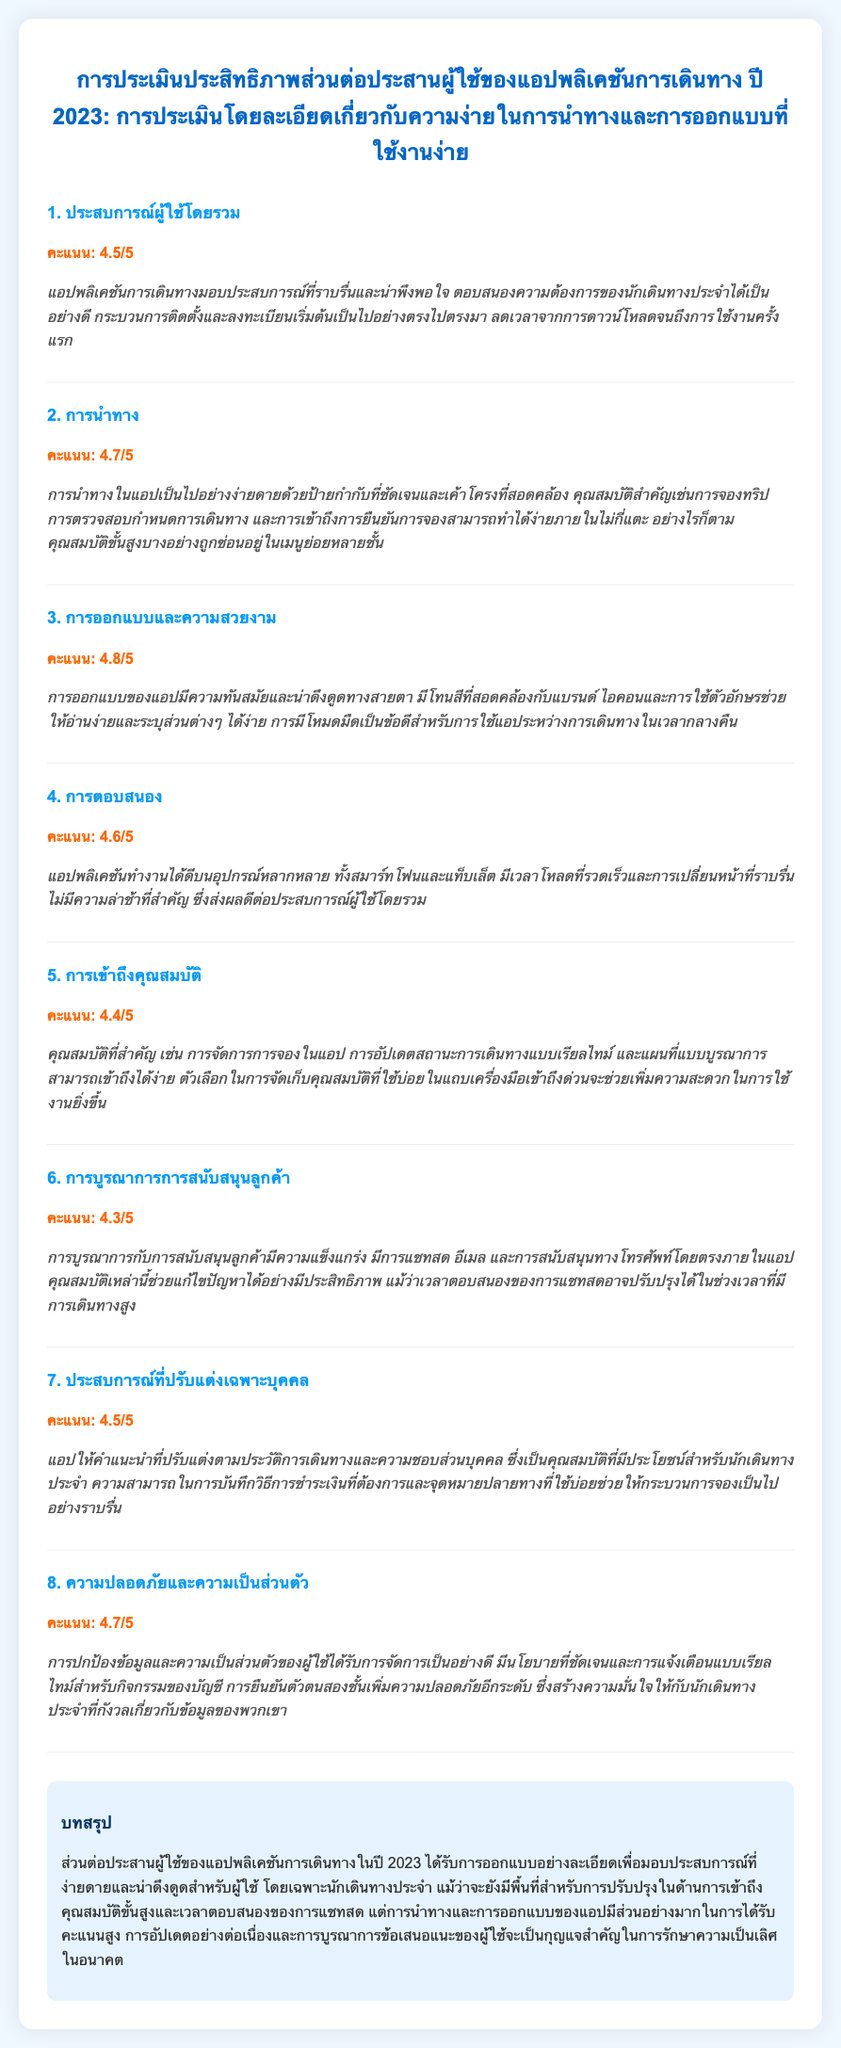What is the overall user experience rating? The overall user experience rating is mentioned in the section titled "ประสบการณ์ผู้ใช้โดยรวม," which is 4.5 out of 5.
Answer: 4.5/5 What feature received the highest score? The feature with the highest score is discussed in the section "การออกแบบและความสวยงาม," which received a score of 4.8 out of 5.
Answer: 4.8/5 How is the navigation rated? The navigation rating is found in the section "การนำทาง," where it is listed as 4.7 out of 5.
Answer: 4.7/5 Which aspect had the lowest score? The aspect with the lowest score appears in the section "การบูรณาการการสนับสนุนลูกค้า," with a rating of 4.3 out of 5.
Answer: 4.3/5 What is the feedback for responsiveness? The feedback related to responsiveness is provided in the section "การตอบสนอง," highlighting the app's performance on various devices.
Answer: แอปพลิเคชันทำงานได้ดีบนอุปกรณ์หลากหลาย What is included in the summary of the conclusion? The summary includes an overall assessment of the app's user interface performance and areas for improvement.
Answer: การออกแบบอย่างละเอียดเพื่อมอบประสบการณ์ที่ง่ายดาย How does the app ensure data protection? The section "ความปลอดภัยและความเป็นส่วนตัว" details how user data protection is managed, including authentication methods.
Answer: การยืนยันตัวตนสองชั้น What feature is suggested for improvement in the app? There are mentions of improvement suggestions in the conclusion, particularly regarding specific features.
Answer: การเข้าถึงคุณสมบัติขั้นสูง Which design feature is beneficial for nighttime use? The feedback in the section "การออกแบบและความสวยงาม" mentions a design feature that helps in nighttime use.
Answer: โหมดมืด 